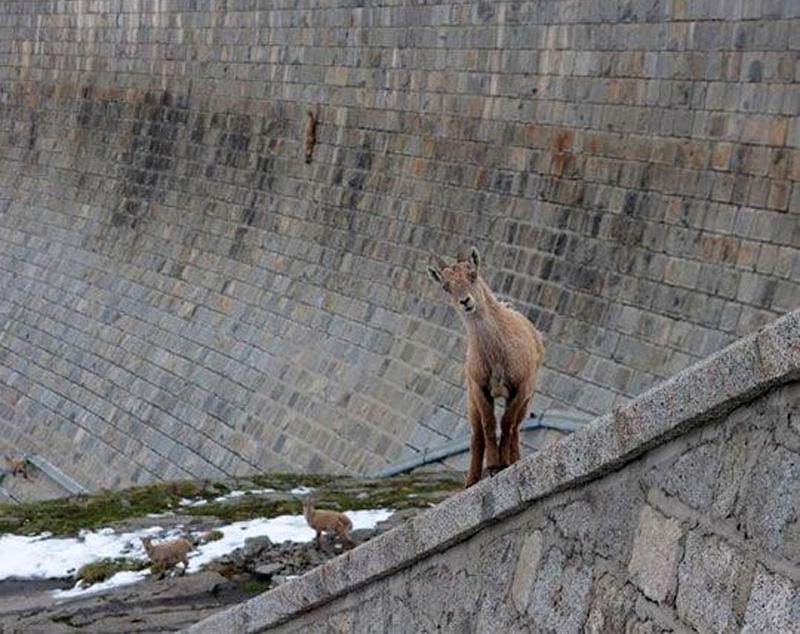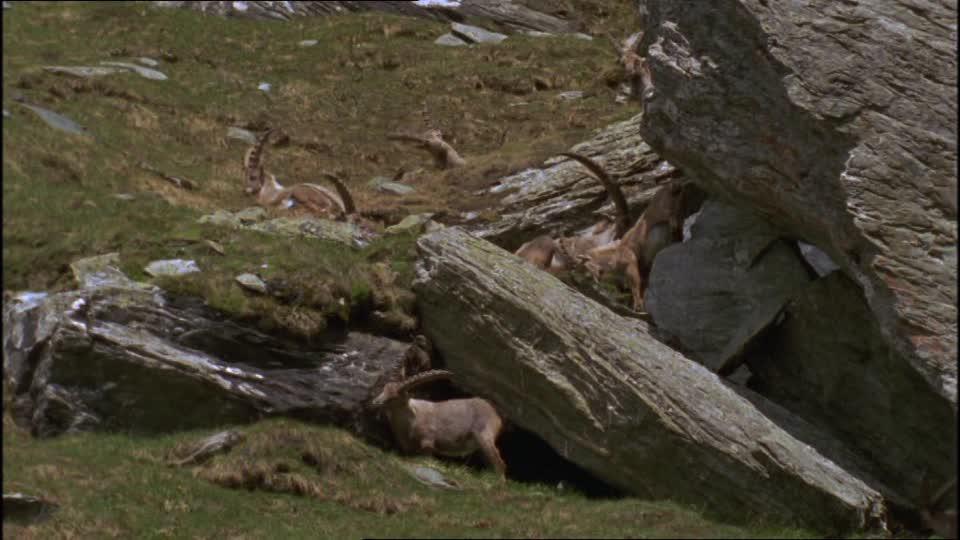The first image is the image on the left, the second image is the image on the right. Evaluate the accuracy of this statement regarding the images: "An image contains only a rightward-facing horned animal in a pose on green grass.". Is it true? Answer yes or no. No. The first image is the image on the left, the second image is the image on the right. Analyze the images presented: Is the assertion "A single animal is standing in the grass in the image on the left." valid? Answer yes or no. No. 